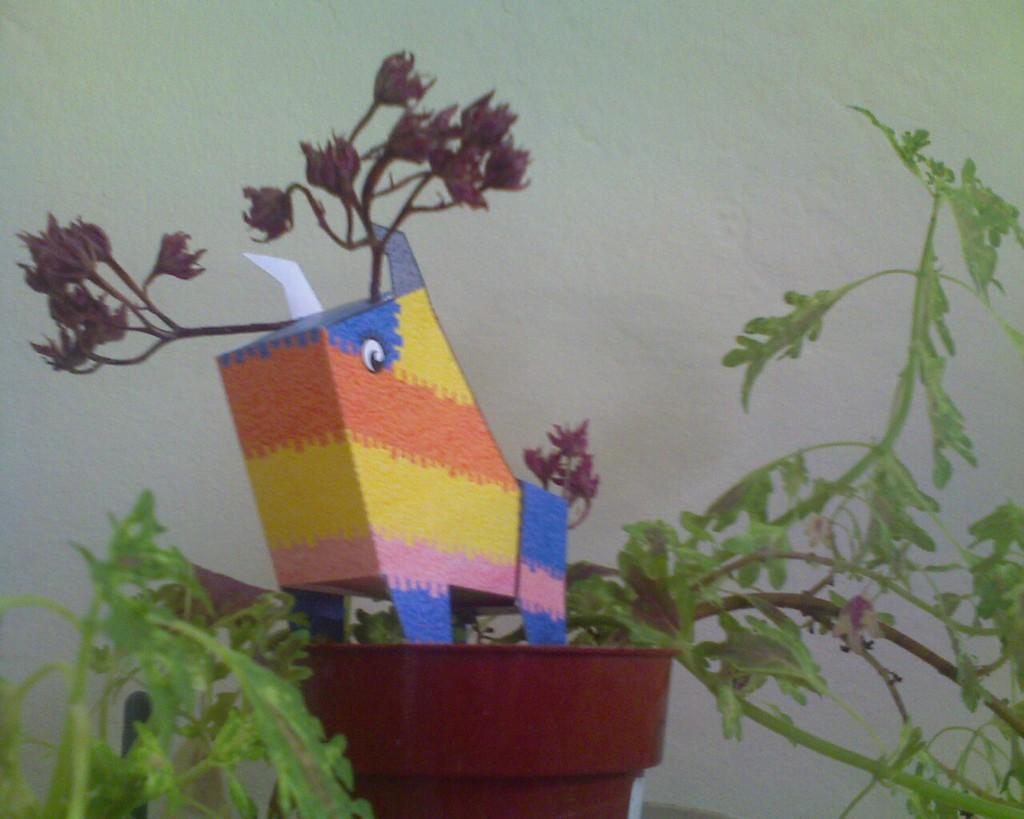What is the main object in the image? There is a plant pot in the image. Are there any other objects visible in the image? Yes, there are other objects in the image. What can be seen in the background of the image? There is a white color wall in the background of the image. What time does the clock show in the image? There is no clock present in the image, so it is not possible to determine the time. 